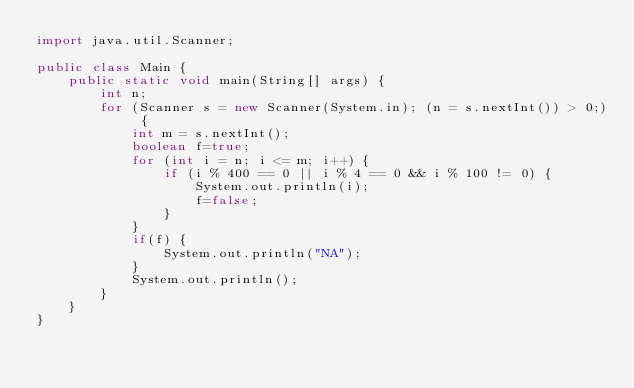Convert code to text. <code><loc_0><loc_0><loc_500><loc_500><_Java_>import java.util.Scanner;

public class Main {
    public static void main(String[] args) {
        int n;
        for (Scanner s = new Scanner(System.in); (n = s.nextInt()) > 0;) {
            int m = s.nextInt();
            boolean f=true;
            for (int i = n; i <= m; i++) {
                if (i % 400 == 0 || i % 4 == 0 && i % 100 != 0) {
                    System.out.println(i);
                    f=false;
                }
            }
            if(f) {
                System.out.println("NA");
            }
            System.out.println();
        }
    }
}
</code> 